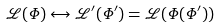<formula> <loc_0><loc_0><loc_500><loc_500>\mathcal { L } ( \Phi ) \leftrightarrow \mathcal { L } ^ { \prime } ( \Phi ^ { \prime } ) = \mathcal { L } ( \Phi ( \Phi ^ { \prime } ) )</formula> 